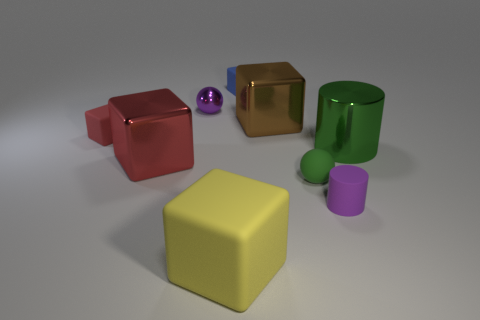What number of spheres have the same material as the green cylinder? There is one sphere that has the same glossy material as the green cylinder. 